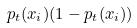<formula> <loc_0><loc_0><loc_500><loc_500>p _ { t } ( x _ { i } ) ( 1 - p _ { t } ( x _ { i } ) )</formula> 